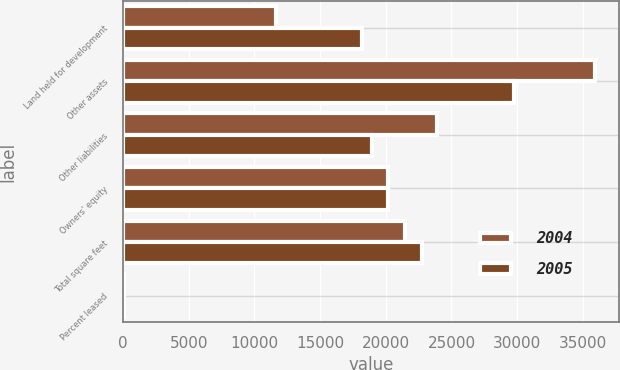Convert chart to OTSL. <chart><loc_0><loc_0><loc_500><loc_500><stacked_bar_chart><ecel><fcel>Land held for development<fcel>Other assets<fcel>Other liabilities<fcel>Owners' equity<fcel>Total square feet<fcel>Percent leased<nl><fcel>2004<fcel>11628<fcel>35959<fcel>23903<fcel>20178.5<fcel>21436<fcel>95.9<nl><fcel>2005<fcel>18174<fcel>29738<fcel>18921<fcel>20178.5<fcel>22763<fcel>95<nl></chart> 